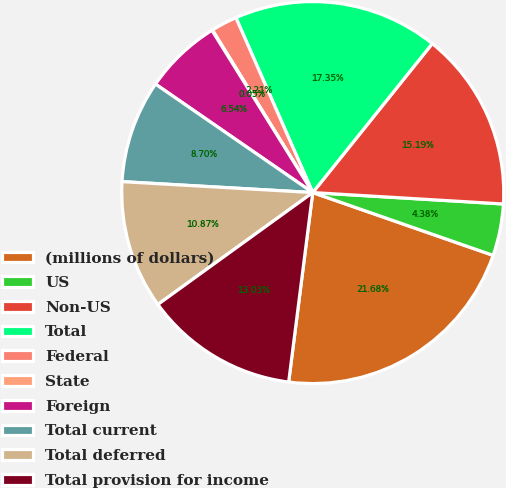Convert chart. <chart><loc_0><loc_0><loc_500><loc_500><pie_chart><fcel>(millions of dollars)<fcel>US<fcel>Non-US<fcel>Total<fcel>Federal<fcel>State<fcel>Foreign<fcel>Total current<fcel>Total deferred<fcel>Total provision for income<nl><fcel>21.68%<fcel>4.38%<fcel>15.19%<fcel>17.35%<fcel>2.21%<fcel>0.05%<fcel>6.54%<fcel>8.7%<fcel>10.87%<fcel>13.03%<nl></chart> 